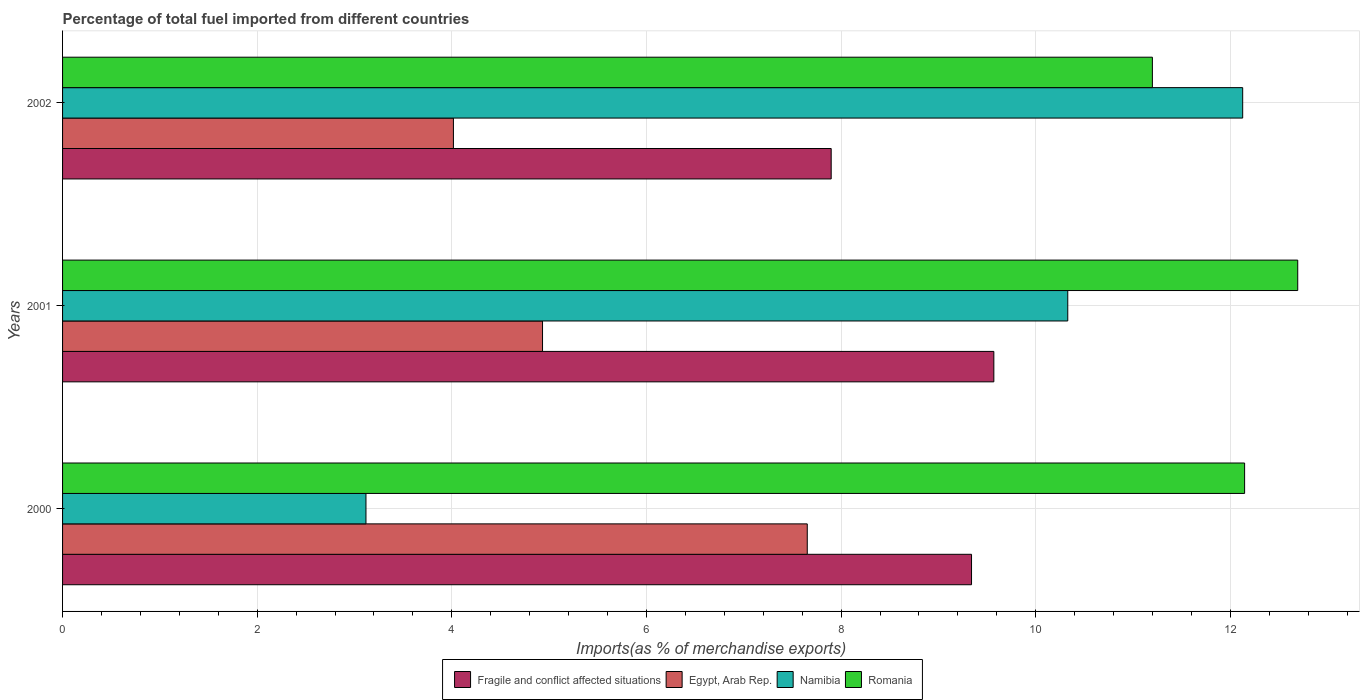How many different coloured bars are there?
Offer a terse response. 4. Are the number of bars on each tick of the Y-axis equal?
Give a very brief answer. Yes. How many bars are there on the 3rd tick from the bottom?
Your answer should be compact. 4. What is the label of the 3rd group of bars from the top?
Your response must be concise. 2000. In how many cases, is the number of bars for a given year not equal to the number of legend labels?
Your response must be concise. 0. What is the percentage of imports to different countries in Namibia in 2001?
Your answer should be compact. 10.33. Across all years, what is the maximum percentage of imports to different countries in Romania?
Make the answer very short. 12.69. Across all years, what is the minimum percentage of imports to different countries in Namibia?
Make the answer very short. 3.12. In which year was the percentage of imports to different countries in Egypt, Arab Rep. maximum?
Provide a short and direct response. 2000. What is the total percentage of imports to different countries in Romania in the graph?
Your answer should be very brief. 36.04. What is the difference between the percentage of imports to different countries in Fragile and conflict affected situations in 2000 and that in 2001?
Provide a short and direct response. -0.23. What is the difference between the percentage of imports to different countries in Fragile and conflict affected situations in 2001 and the percentage of imports to different countries in Namibia in 2002?
Provide a short and direct response. -2.56. What is the average percentage of imports to different countries in Fragile and conflict affected situations per year?
Your answer should be compact. 8.94. In the year 2000, what is the difference between the percentage of imports to different countries in Romania and percentage of imports to different countries in Namibia?
Offer a terse response. 9.03. What is the ratio of the percentage of imports to different countries in Romania in 2000 to that in 2001?
Offer a terse response. 0.96. Is the difference between the percentage of imports to different countries in Romania in 2000 and 2001 greater than the difference between the percentage of imports to different countries in Namibia in 2000 and 2001?
Give a very brief answer. Yes. What is the difference between the highest and the second highest percentage of imports to different countries in Egypt, Arab Rep.?
Your answer should be compact. 2.72. What is the difference between the highest and the lowest percentage of imports to different countries in Namibia?
Offer a very short reply. 9.01. In how many years, is the percentage of imports to different countries in Fragile and conflict affected situations greater than the average percentage of imports to different countries in Fragile and conflict affected situations taken over all years?
Keep it short and to the point. 2. Is the sum of the percentage of imports to different countries in Namibia in 2001 and 2002 greater than the maximum percentage of imports to different countries in Fragile and conflict affected situations across all years?
Your answer should be very brief. Yes. What does the 1st bar from the top in 2000 represents?
Give a very brief answer. Romania. What does the 1st bar from the bottom in 2000 represents?
Give a very brief answer. Fragile and conflict affected situations. How many years are there in the graph?
Offer a very short reply. 3. Are the values on the major ticks of X-axis written in scientific E-notation?
Your response must be concise. No. Where does the legend appear in the graph?
Make the answer very short. Bottom center. What is the title of the graph?
Give a very brief answer. Percentage of total fuel imported from different countries. What is the label or title of the X-axis?
Offer a terse response. Imports(as % of merchandise exports). What is the Imports(as % of merchandise exports) of Fragile and conflict affected situations in 2000?
Your response must be concise. 9.34. What is the Imports(as % of merchandise exports) in Egypt, Arab Rep. in 2000?
Keep it short and to the point. 7.65. What is the Imports(as % of merchandise exports) in Namibia in 2000?
Your answer should be compact. 3.12. What is the Imports(as % of merchandise exports) in Romania in 2000?
Provide a short and direct response. 12.15. What is the Imports(as % of merchandise exports) of Fragile and conflict affected situations in 2001?
Provide a succinct answer. 9.57. What is the Imports(as % of merchandise exports) of Egypt, Arab Rep. in 2001?
Provide a short and direct response. 4.93. What is the Imports(as % of merchandise exports) in Namibia in 2001?
Provide a short and direct response. 10.33. What is the Imports(as % of merchandise exports) in Romania in 2001?
Ensure brevity in your answer.  12.69. What is the Imports(as % of merchandise exports) of Fragile and conflict affected situations in 2002?
Keep it short and to the point. 7.9. What is the Imports(as % of merchandise exports) in Egypt, Arab Rep. in 2002?
Your answer should be compact. 4.02. What is the Imports(as % of merchandise exports) in Namibia in 2002?
Provide a short and direct response. 12.13. What is the Imports(as % of merchandise exports) in Romania in 2002?
Your response must be concise. 11.2. Across all years, what is the maximum Imports(as % of merchandise exports) of Fragile and conflict affected situations?
Keep it short and to the point. 9.57. Across all years, what is the maximum Imports(as % of merchandise exports) in Egypt, Arab Rep.?
Your response must be concise. 7.65. Across all years, what is the maximum Imports(as % of merchandise exports) of Namibia?
Provide a short and direct response. 12.13. Across all years, what is the maximum Imports(as % of merchandise exports) in Romania?
Your answer should be compact. 12.69. Across all years, what is the minimum Imports(as % of merchandise exports) of Fragile and conflict affected situations?
Offer a terse response. 7.9. Across all years, what is the minimum Imports(as % of merchandise exports) in Egypt, Arab Rep.?
Give a very brief answer. 4.02. Across all years, what is the minimum Imports(as % of merchandise exports) in Namibia?
Provide a short and direct response. 3.12. Across all years, what is the minimum Imports(as % of merchandise exports) in Romania?
Your answer should be compact. 11.2. What is the total Imports(as % of merchandise exports) of Fragile and conflict affected situations in the graph?
Provide a short and direct response. 26.81. What is the total Imports(as % of merchandise exports) in Egypt, Arab Rep. in the graph?
Your response must be concise. 16.6. What is the total Imports(as % of merchandise exports) of Namibia in the graph?
Ensure brevity in your answer.  25.57. What is the total Imports(as % of merchandise exports) of Romania in the graph?
Offer a terse response. 36.04. What is the difference between the Imports(as % of merchandise exports) of Fragile and conflict affected situations in 2000 and that in 2001?
Offer a terse response. -0.23. What is the difference between the Imports(as % of merchandise exports) of Egypt, Arab Rep. in 2000 and that in 2001?
Make the answer very short. 2.72. What is the difference between the Imports(as % of merchandise exports) in Namibia in 2000 and that in 2001?
Offer a very short reply. -7.21. What is the difference between the Imports(as % of merchandise exports) in Romania in 2000 and that in 2001?
Ensure brevity in your answer.  -0.55. What is the difference between the Imports(as % of merchandise exports) in Fragile and conflict affected situations in 2000 and that in 2002?
Give a very brief answer. 1.44. What is the difference between the Imports(as % of merchandise exports) in Egypt, Arab Rep. in 2000 and that in 2002?
Ensure brevity in your answer.  3.64. What is the difference between the Imports(as % of merchandise exports) of Namibia in 2000 and that in 2002?
Ensure brevity in your answer.  -9.01. What is the difference between the Imports(as % of merchandise exports) in Romania in 2000 and that in 2002?
Make the answer very short. 0.95. What is the difference between the Imports(as % of merchandise exports) in Fragile and conflict affected situations in 2001 and that in 2002?
Make the answer very short. 1.67. What is the difference between the Imports(as % of merchandise exports) in Egypt, Arab Rep. in 2001 and that in 2002?
Your response must be concise. 0.92. What is the difference between the Imports(as % of merchandise exports) in Namibia in 2001 and that in 2002?
Offer a very short reply. -1.8. What is the difference between the Imports(as % of merchandise exports) of Romania in 2001 and that in 2002?
Keep it short and to the point. 1.49. What is the difference between the Imports(as % of merchandise exports) of Fragile and conflict affected situations in 2000 and the Imports(as % of merchandise exports) of Egypt, Arab Rep. in 2001?
Your response must be concise. 4.41. What is the difference between the Imports(as % of merchandise exports) in Fragile and conflict affected situations in 2000 and the Imports(as % of merchandise exports) in Namibia in 2001?
Provide a succinct answer. -0.99. What is the difference between the Imports(as % of merchandise exports) of Fragile and conflict affected situations in 2000 and the Imports(as % of merchandise exports) of Romania in 2001?
Your response must be concise. -3.35. What is the difference between the Imports(as % of merchandise exports) in Egypt, Arab Rep. in 2000 and the Imports(as % of merchandise exports) in Namibia in 2001?
Your answer should be compact. -2.68. What is the difference between the Imports(as % of merchandise exports) of Egypt, Arab Rep. in 2000 and the Imports(as % of merchandise exports) of Romania in 2001?
Provide a succinct answer. -5.04. What is the difference between the Imports(as % of merchandise exports) of Namibia in 2000 and the Imports(as % of merchandise exports) of Romania in 2001?
Make the answer very short. -9.57. What is the difference between the Imports(as % of merchandise exports) of Fragile and conflict affected situations in 2000 and the Imports(as % of merchandise exports) of Egypt, Arab Rep. in 2002?
Your answer should be very brief. 5.32. What is the difference between the Imports(as % of merchandise exports) of Fragile and conflict affected situations in 2000 and the Imports(as % of merchandise exports) of Namibia in 2002?
Give a very brief answer. -2.79. What is the difference between the Imports(as % of merchandise exports) of Fragile and conflict affected situations in 2000 and the Imports(as % of merchandise exports) of Romania in 2002?
Provide a succinct answer. -1.86. What is the difference between the Imports(as % of merchandise exports) of Egypt, Arab Rep. in 2000 and the Imports(as % of merchandise exports) of Namibia in 2002?
Your answer should be very brief. -4.47. What is the difference between the Imports(as % of merchandise exports) in Egypt, Arab Rep. in 2000 and the Imports(as % of merchandise exports) in Romania in 2002?
Offer a terse response. -3.55. What is the difference between the Imports(as % of merchandise exports) of Namibia in 2000 and the Imports(as % of merchandise exports) of Romania in 2002?
Your answer should be compact. -8.08. What is the difference between the Imports(as % of merchandise exports) in Fragile and conflict affected situations in 2001 and the Imports(as % of merchandise exports) in Egypt, Arab Rep. in 2002?
Your answer should be compact. 5.55. What is the difference between the Imports(as % of merchandise exports) in Fragile and conflict affected situations in 2001 and the Imports(as % of merchandise exports) in Namibia in 2002?
Offer a very short reply. -2.56. What is the difference between the Imports(as % of merchandise exports) in Fragile and conflict affected situations in 2001 and the Imports(as % of merchandise exports) in Romania in 2002?
Give a very brief answer. -1.63. What is the difference between the Imports(as % of merchandise exports) in Egypt, Arab Rep. in 2001 and the Imports(as % of merchandise exports) in Namibia in 2002?
Provide a short and direct response. -7.19. What is the difference between the Imports(as % of merchandise exports) in Egypt, Arab Rep. in 2001 and the Imports(as % of merchandise exports) in Romania in 2002?
Your answer should be compact. -6.27. What is the difference between the Imports(as % of merchandise exports) of Namibia in 2001 and the Imports(as % of merchandise exports) of Romania in 2002?
Offer a terse response. -0.87. What is the average Imports(as % of merchandise exports) of Fragile and conflict affected situations per year?
Offer a terse response. 8.94. What is the average Imports(as % of merchandise exports) in Egypt, Arab Rep. per year?
Offer a very short reply. 5.53. What is the average Imports(as % of merchandise exports) of Namibia per year?
Your answer should be very brief. 8.52. What is the average Imports(as % of merchandise exports) of Romania per year?
Your answer should be compact. 12.01. In the year 2000, what is the difference between the Imports(as % of merchandise exports) in Fragile and conflict affected situations and Imports(as % of merchandise exports) in Egypt, Arab Rep.?
Offer a terse response. 1.69. In the year 2000, what is the difference between the Imports(as % of merchandise exports) in Fragile and conflict affected situations and Imports(as % of merchandise exports) in Namibia?
Provide a succinct answer. 6.22. In the year 2000, what is the difference between the Imports(as % of merchandise exports) in Fragile and conflict affected situations and Imports(as % of merchandise exports) in Romania?
Your response must be concise. -2.81. In the year 2000, what is the difference between the Imports(as % of merchandise exports) of Egypt, Arab Rep. and Imports(as % of merchandise exports) of Namibia?
Offer a terse response. 4.53. In the year 2000, what is the difference between the Imports(as % of merchandise exports) of Egypt, Arab Rep. and Imports(as % of merchandise exports) of Romania?
Ensure brevity in your answer.  -4.49. In the year 2000, what is the difference between the Imports(as % of merchandise exports) of Namibia and Imports(as % of merchandise exports) of Romania?
Provide a short and direct response. -9.03. In the year 2001, what is the difference between the Imports(as % of merchandise exports) in Fragile and conflict affected situations and Imports(as % of merchandise exports) in Egypt, Arab Rep.?
Keep it short and to the point. 4.64. In the year 2001, what is the difference between the Imports(as % of merchandise exports) of Fragile and conflict affected situations and Imports(as % of merchandise exports) of Namibia?
Keep it short and to the point. -0.76. In the year 2001, what is the difference between the Imports(as % of merchandise exports) in Fragile and conflict affected situations and Imports(as % of merchandise exports) in Romania?
Offer a terse response. -3.12. In the year 2001, what is the difference between the Imports(as % of merchandise exports) in Egypt, Arab Rep. and Imports(as % of merchandise exports) in Namibia?
Make the answer very short. -5.4. In the year 2001, what is the difference between the Imports(as % of merchandise exports) of Egypt, Arab Rep. and Imports(as % of merchandise exports) of Romania?
Ensure brevity in your answer.  -7.76. In the year 2001, what is the difference between the Imports(as % of merchandise exports) of Namibia and Imports(as % of merchandise exports) of Romania?
Offer a terse response. -2.36. In the year 2002, what is the difference between the Imports(as % of merchandise exports) in Fragile and conflict affected situations and Imports(as % of merchandise exports) in Egypt, Arab Rep.?
Provide a short and direct response. 3.88. In the year 2002, what is the difference between the Imports(as % of merchandise exports) of Fragile and conflict affected situations and Imports(as % of merchandise exports) of Namibia?
Offer a very short reply. -4.23. In the year 2002, what is the difference between the Imports(as % of merchandise exports) of Fragile and conflict affected situations and Imports(as % of merchandise exports) of Romania?
Offer a terse response. -3.3. In the year 2002, what is the difference between the Imports(as % of merchandise exports) in Egypt, Arab Rep. and Imports(as % of merchandise exports) in Namibia?
Your answer should be compact. -8.11. In the year 2002, what is the difference between the Imports(as % of merchandise exports) of Egypt, Arab Rep. and Imports(as % of merchandise exports) of Romania?
Offer a terse response. -7.18. In the year 2002, what is the difference between the Imports(as % of merchandise exports) of Namibia and Imports(as % of merchandise exports) of Romania?
Provide a succinct answer. 0.93. What is the ratio of the Imports(as % of merchandise exports) in Fragile and conflict affected situations in 2000 to that in 2001?
Provide a succinct answer. 0.98. What is the ratio of the Imports(as % of merchandise exports) in Egypt, Arab Rep. in 2000 to that in 2001?
Keep it short and to the point. 1.55. What is the ratio of the Imports(as % of merchandise exports) in Namibia in 2000 to that in 2001?
Your response must be concise. 0.3. What is the ratio of the Imports(as % of merchandise exports) in Romania in 2000 to that in 2001?
Provide a short and direct response. 0.96. What is the ratio of the Imports(as % of merchandise exports) in Fragile and conflict affected situations in 2000 to that in 2002?
Make the answer very short. 1.18. What is the ratio of the Imports(as % of merchandise exports) in Egypt, Arab Rep. in 2000 to that in 2002?
Offer a terse response. 1.91. What is the ratio of the Imports(as % of merchandise exports) of Namibia in 2000 to that in 2002?
Ensure brevity in your answer.  0.26. What is the ratio of the Imports(as % of merchandise exports) in Romania in 2000 to that in 2002?
Offer a terse response. 1.08. What is the ratio of the Imports(as % of merchandise exports) of Fragile and conflict affected situations in 2001 to that in 2002?
Give a very brief answer. 1.21. What is the ratio of the Imports(as % of merchandise exports) of Egypt, Arab Rep. in 2001 to that in 2002?
Provide a short and direct response. 1.23. What is the ratio of the Imports(as % of merchandise exports) in Namibia in 2001 to that in 2002?
Offer a terse response. 0.85. What is the ratio of the Imports(as % of merchandise exports) of Romania in 2001 to that in 2002?
Provide a short and direct response. 1.13. What is the difference between the highest and the second highest Imports(as % of merchandise exports) of Fragile and conflict affected situations?
Your answer should be compact. 0.23. What is the difference between the highest and the second highest Imports(as % of merchandise exports) in Egypt, Arab Rep.?
Keep it short and to the point. 2.72. What is the difference between the highest and the second highest Imports(as % of merchandise exports) in Namibia?
Provide a short and direct response. 1.8. What is the difference between the highest and the second highest Imports(as % of merchandise exports) of Romania?
Your answer should be compact. 0.55. What is the difference between the highest and the lowest Imports(as % of merchandise exports) in Fragile and conflict affected situations?
Offer a very short reply. 1.67. What is the difference between the highest and the lowest Imports(as % of merchandise exports) in Egypt, Arab Rep.?
Offer a very short reply. 3.64. What is the difference between the highest and the lowest Imports(as % of merchandise exports) in Namibia?
Keep it short and to the point. 9.01. What is the difference between the highest and the lowest Imports(as % of merchandise exports) in Romania?
Your answer should be very brief. 1.49. 